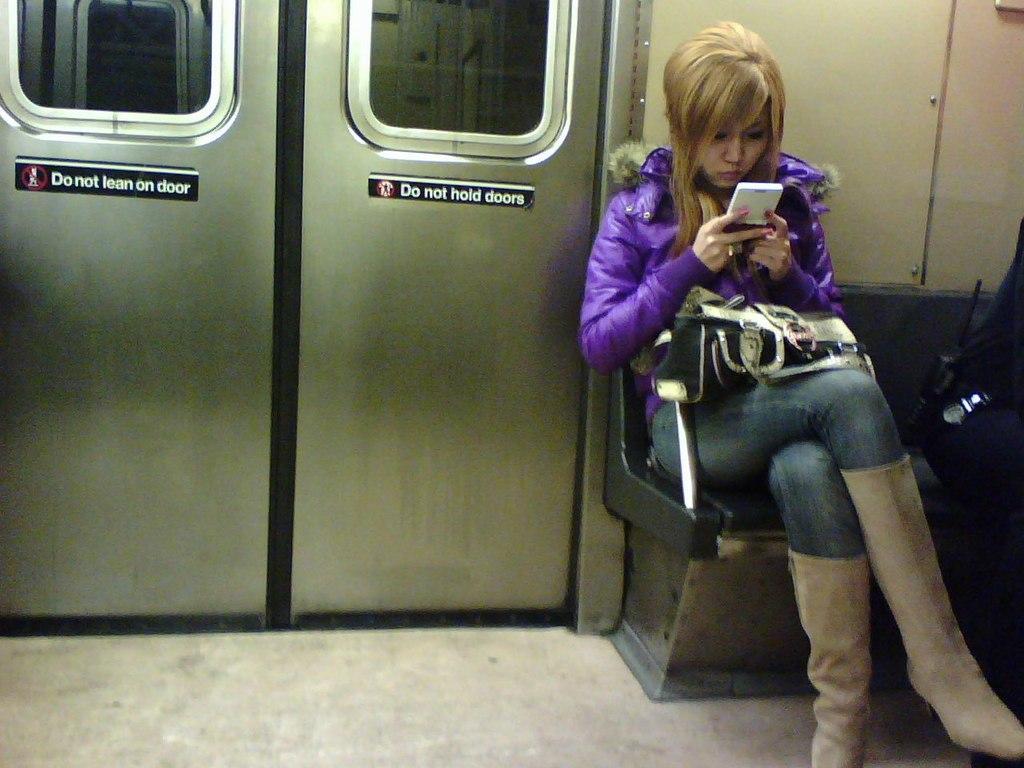Can you describe this image briefly? In the foreground I can see a woman is sitting on the bench and holding a mobile in hand and a person is sitting on the bench. In the background I can see doors and a wall. This image is taken may be in a room. 